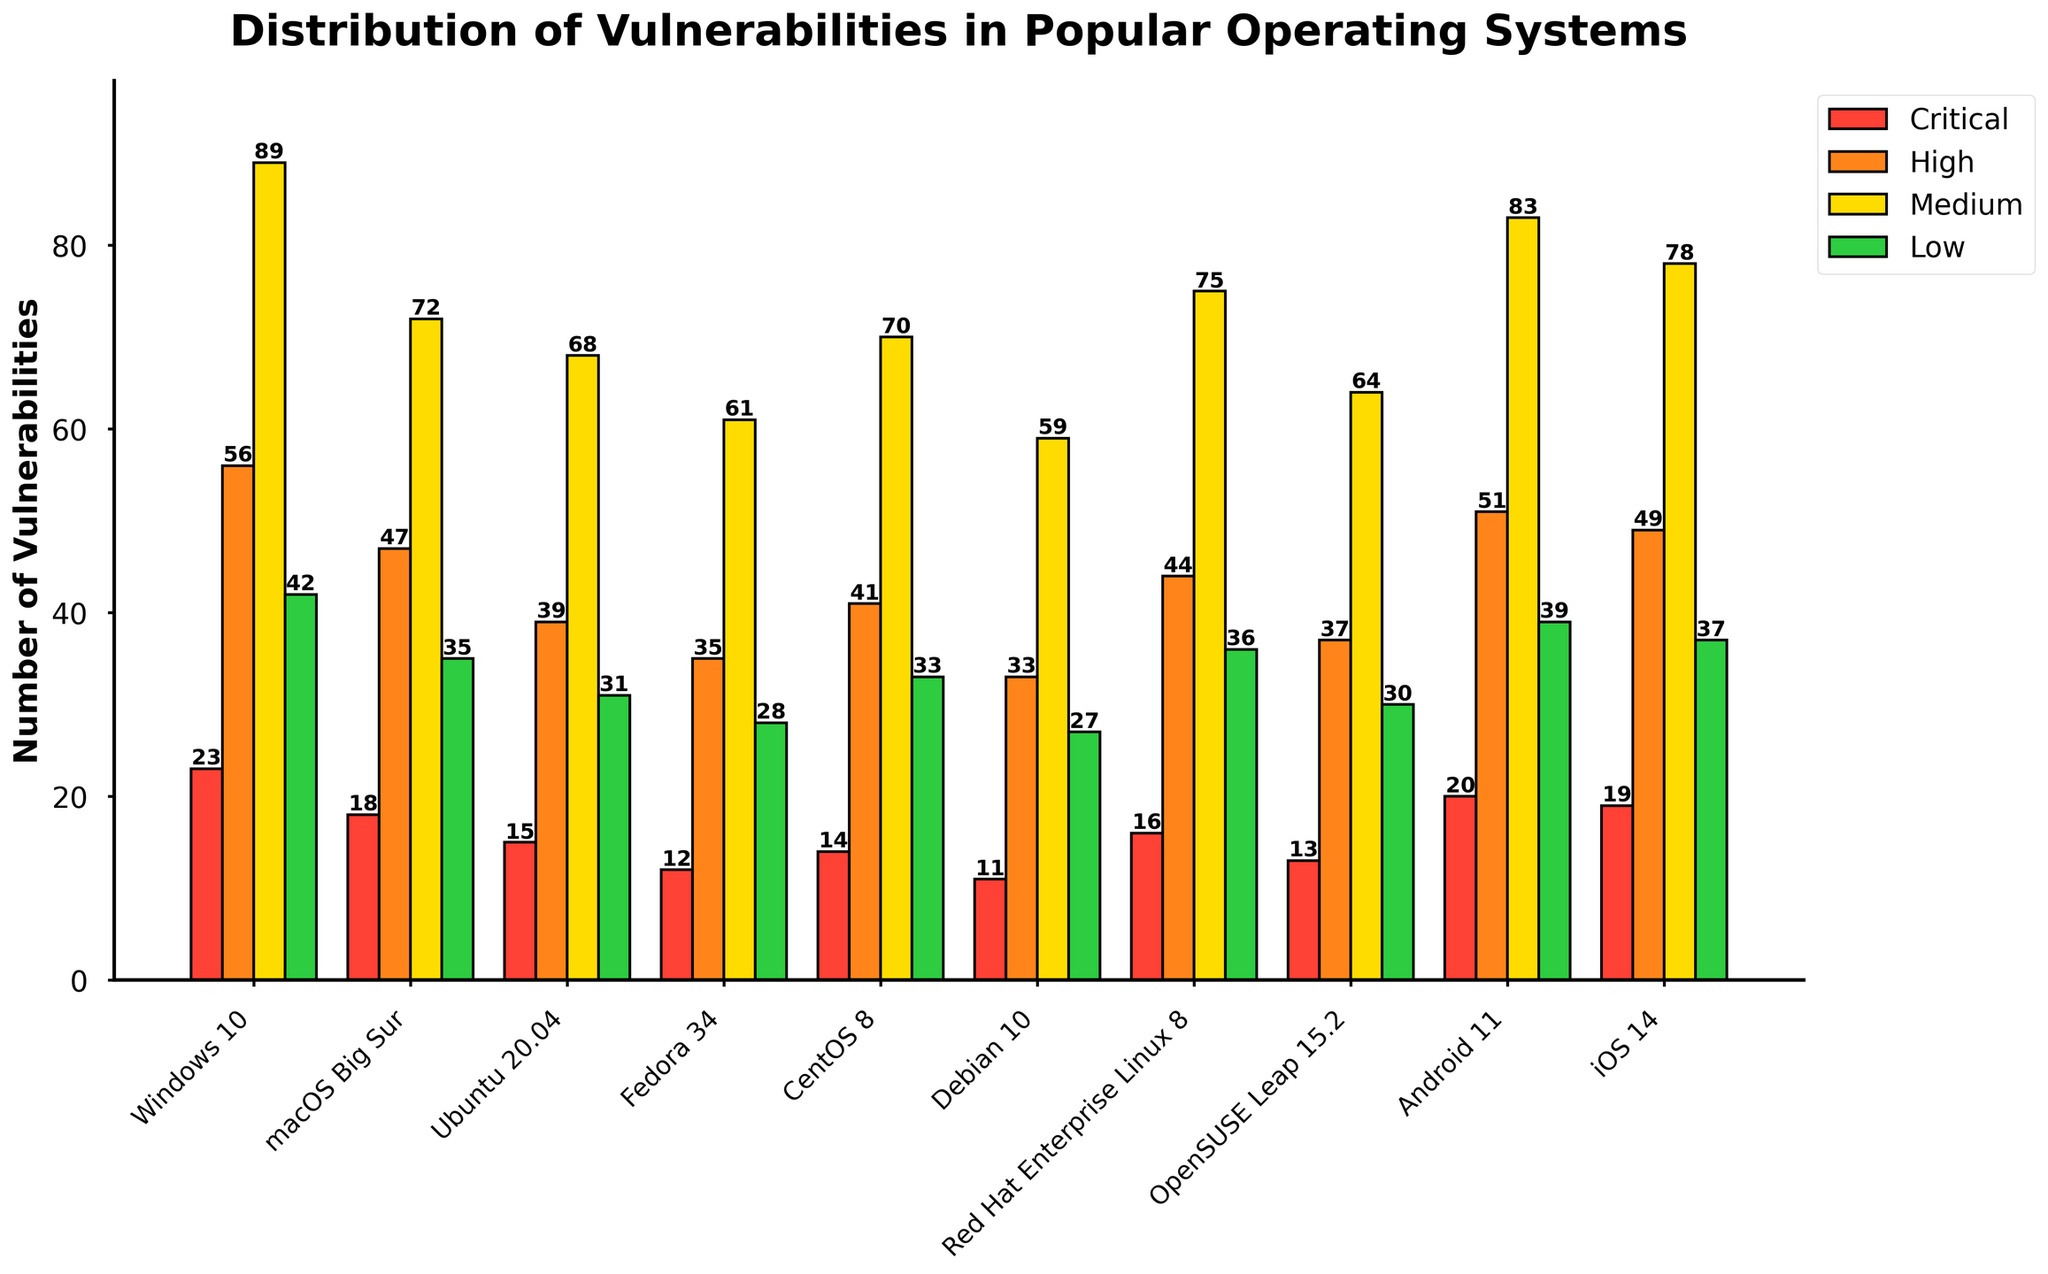Which operating system has the highest number of critical vulnerabilities? Look at each bar corresponding to critical vulnerabilities. The highest bar belongs to Windows 10 with 23 vulnerabilities.
Answer: Windows 10 Which operating system has fewer high vulnerabilities, Ubuntu 20.04 or Fedora 34? Compare the bars corresponding to high vulnerabilities for Ubuntu 20.04 and Fedora 34. Ubuntu 20.04 has 39 vulnerabilities, and Fedora 34 has 35 vulnerabilities.
Answer: Fedora 34 What is the average number of medium vulnerabilities across all operating systems? Sum the number of medium vulnerabilities for all operating systems (89 + 72 + 68 + 61 + 70 + 59 + 75 + 64 + 83 + 78) = 719. There are 10 operating systems, so the average is 719 / 10 = 71.9.
Answer: 71.9 Which operating system has the smallest difference between critical and low vulnerabilities? Calculate the difference for each OS: Windows 10 (23-42=19), macOS Big Sur (18-35=17), Ubuntu 20.04 (15-31=16), Fedora 34 (12-28=16), CentOS 8 (14-33=19), Debian 10 (11-27=16), Red Hat Enterprise Linux 8 (16-36=20), OpenSUSE Leap 15.2 (13-30=17), Android 11 (20-39=19), iOS 14 (19-37=18). The smallest difference is 16 for Ubuntu 20.04, Fedora 34, and Debian 10.
Answer: Ubuntu 20.04, Fedora 34, Debian 10 How many operating systems have more than 70 medium vulnerabilities? Count the operating systems with medium vulnerabilities greater than 70: Windows 10, macOS Big Sur, CentOS 8, Red Hat Enterprise Linux 8, Android 11, and iOS 14. There are 6 such operating systems.
Answer: 6 Which operating system has the lowest number of low vulnerabilities, and what is the exact count? Identify the lowest bar in the low vulnerabilities category. Debian 10 has the lowest with 27 vulnerabilities.
Answer: Debian 10, 27 By how much do high vulnerabilities in macOS Big Sur exceed those in OpenSUSE Leap 15.2? Subtract the number of high vulnerabilities in OpenSUSE Leap 15.2 from macOS Big Sur. macOS Big Sur (47) - OpenSUSE Leap 15.2 (37) = 10.
Answer: 10 How many total vulnerabilities (sum of all types) are present in Windows 10? Sum all types of vulnerabilities in Windows 10: 23 (critical) + 56 (high) + 89 (medium) + 42 (low) = 210.
Answer: 210 